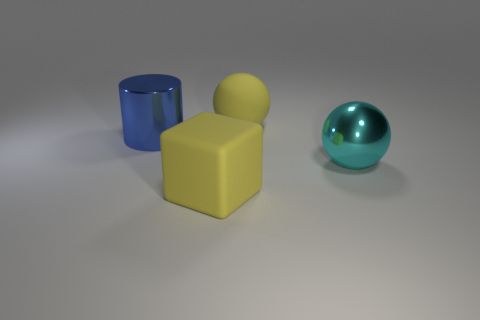What material is the large sphere in front of the blue cylinder?
Offer a very short reply. Metal. Are there more rubber blocks than large metal things?
Your answer should be very brief. No. Does the big yellow matte thing that is in front of the big shiny cylinder have the same shape as the blue shiny object?
Provide a short and direct response. No. What number of objects are in front of the big blue metal cylinder and behind the cylinder?
Provide a succinct answer. 0. What number of other large objects are the same shape as the big cyan metallic thing?
Offer a very short reply. 1. The large metallic object that is to the right of the matte block that is in front of the large blue cylinder is what color?
Provide a succinct answer. Cyan. There is a blue shiny thing; is it the same shape as the large cyan metallic thing in front of the large blue shiny object?
Make the answer very short. No. What material is the large ball behind the big metallic cylinder to the left of the big sphere that is on the left side of the metallic sphere?
Offer a very short reply. Rubber. Is there a block of the same size as the rubber ball?
Keep it short and to the point. Yes. What is the size of the cyan ball that is made of the same material as the large blue thing?
Provide a short and direct response. Large. 